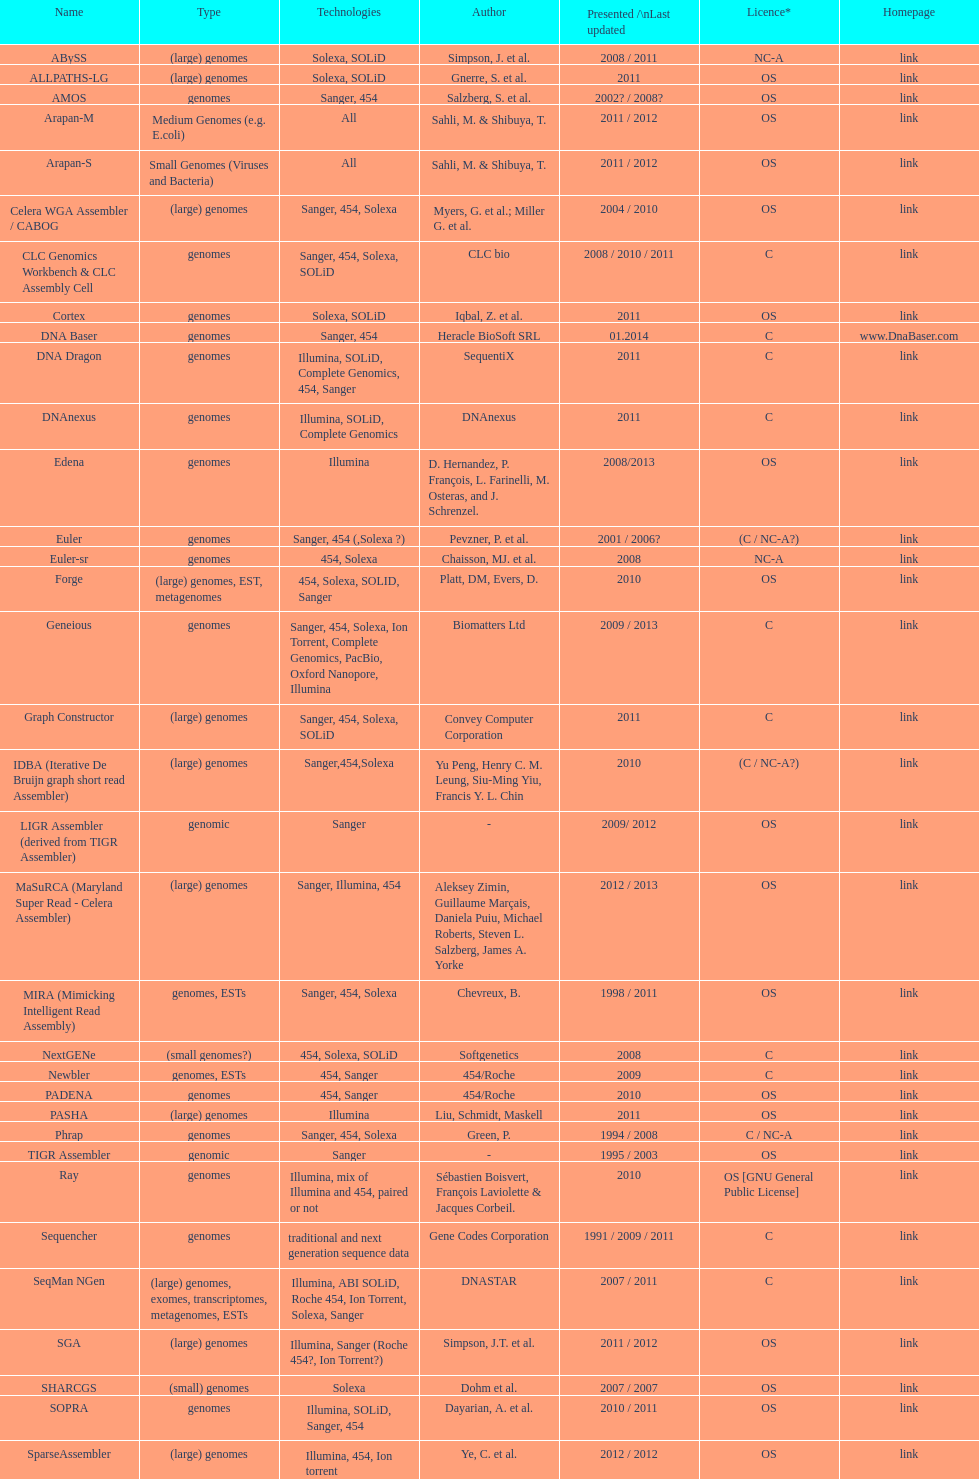What is the newest presentation or updated? DNA Baser. 